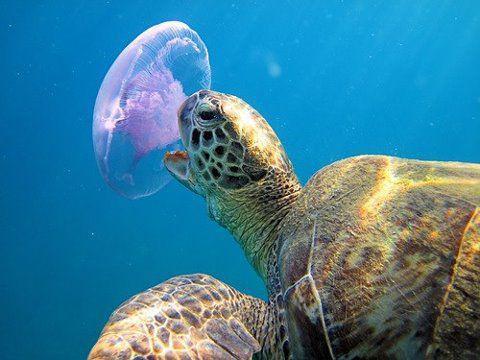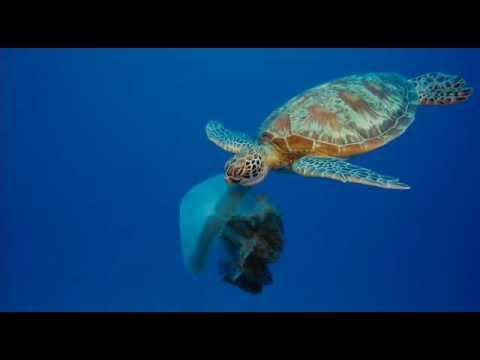The first image is the image on the left, the second image is the image on the right. Analyze the images presented: Is the assertion "A sea turtle with distinctly textured skin has its open mouth next to a purplish saucer-shaped jellyfish." valid? Answer yes or no. Yes. The first image is the image on the left, the second image is the image on the right. Evaluate the accuracy of this statement regarding the images: "There is a sea turtle that is taking a bite at what appears to be a purple jellyfish.". Is it true? Answer yes or no. Yes. 